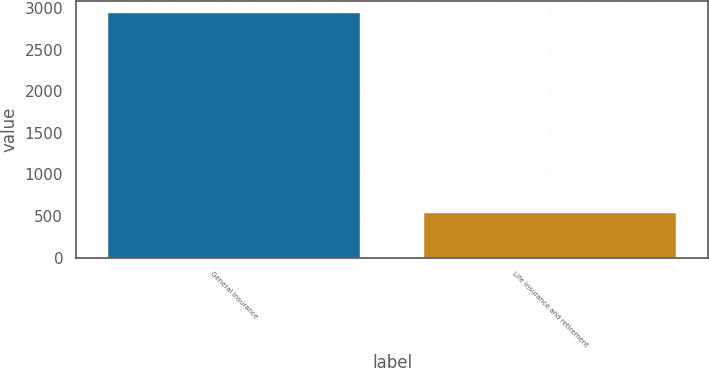Convert chart to OTSL. <chart><loc_0><loc_0><loc_500><loc_500><bar_chart><fcel>General insurance<fcel>Life insurance and retirement<nl><fcel>2937<fcel>536<nl></chart> 